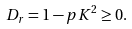Convert formula to latex. <formula><loc_0><loc_0><loc_500><loc_500>D _ { r } = 1 - p K ^ { 2 } \geq 0 .</formula> 